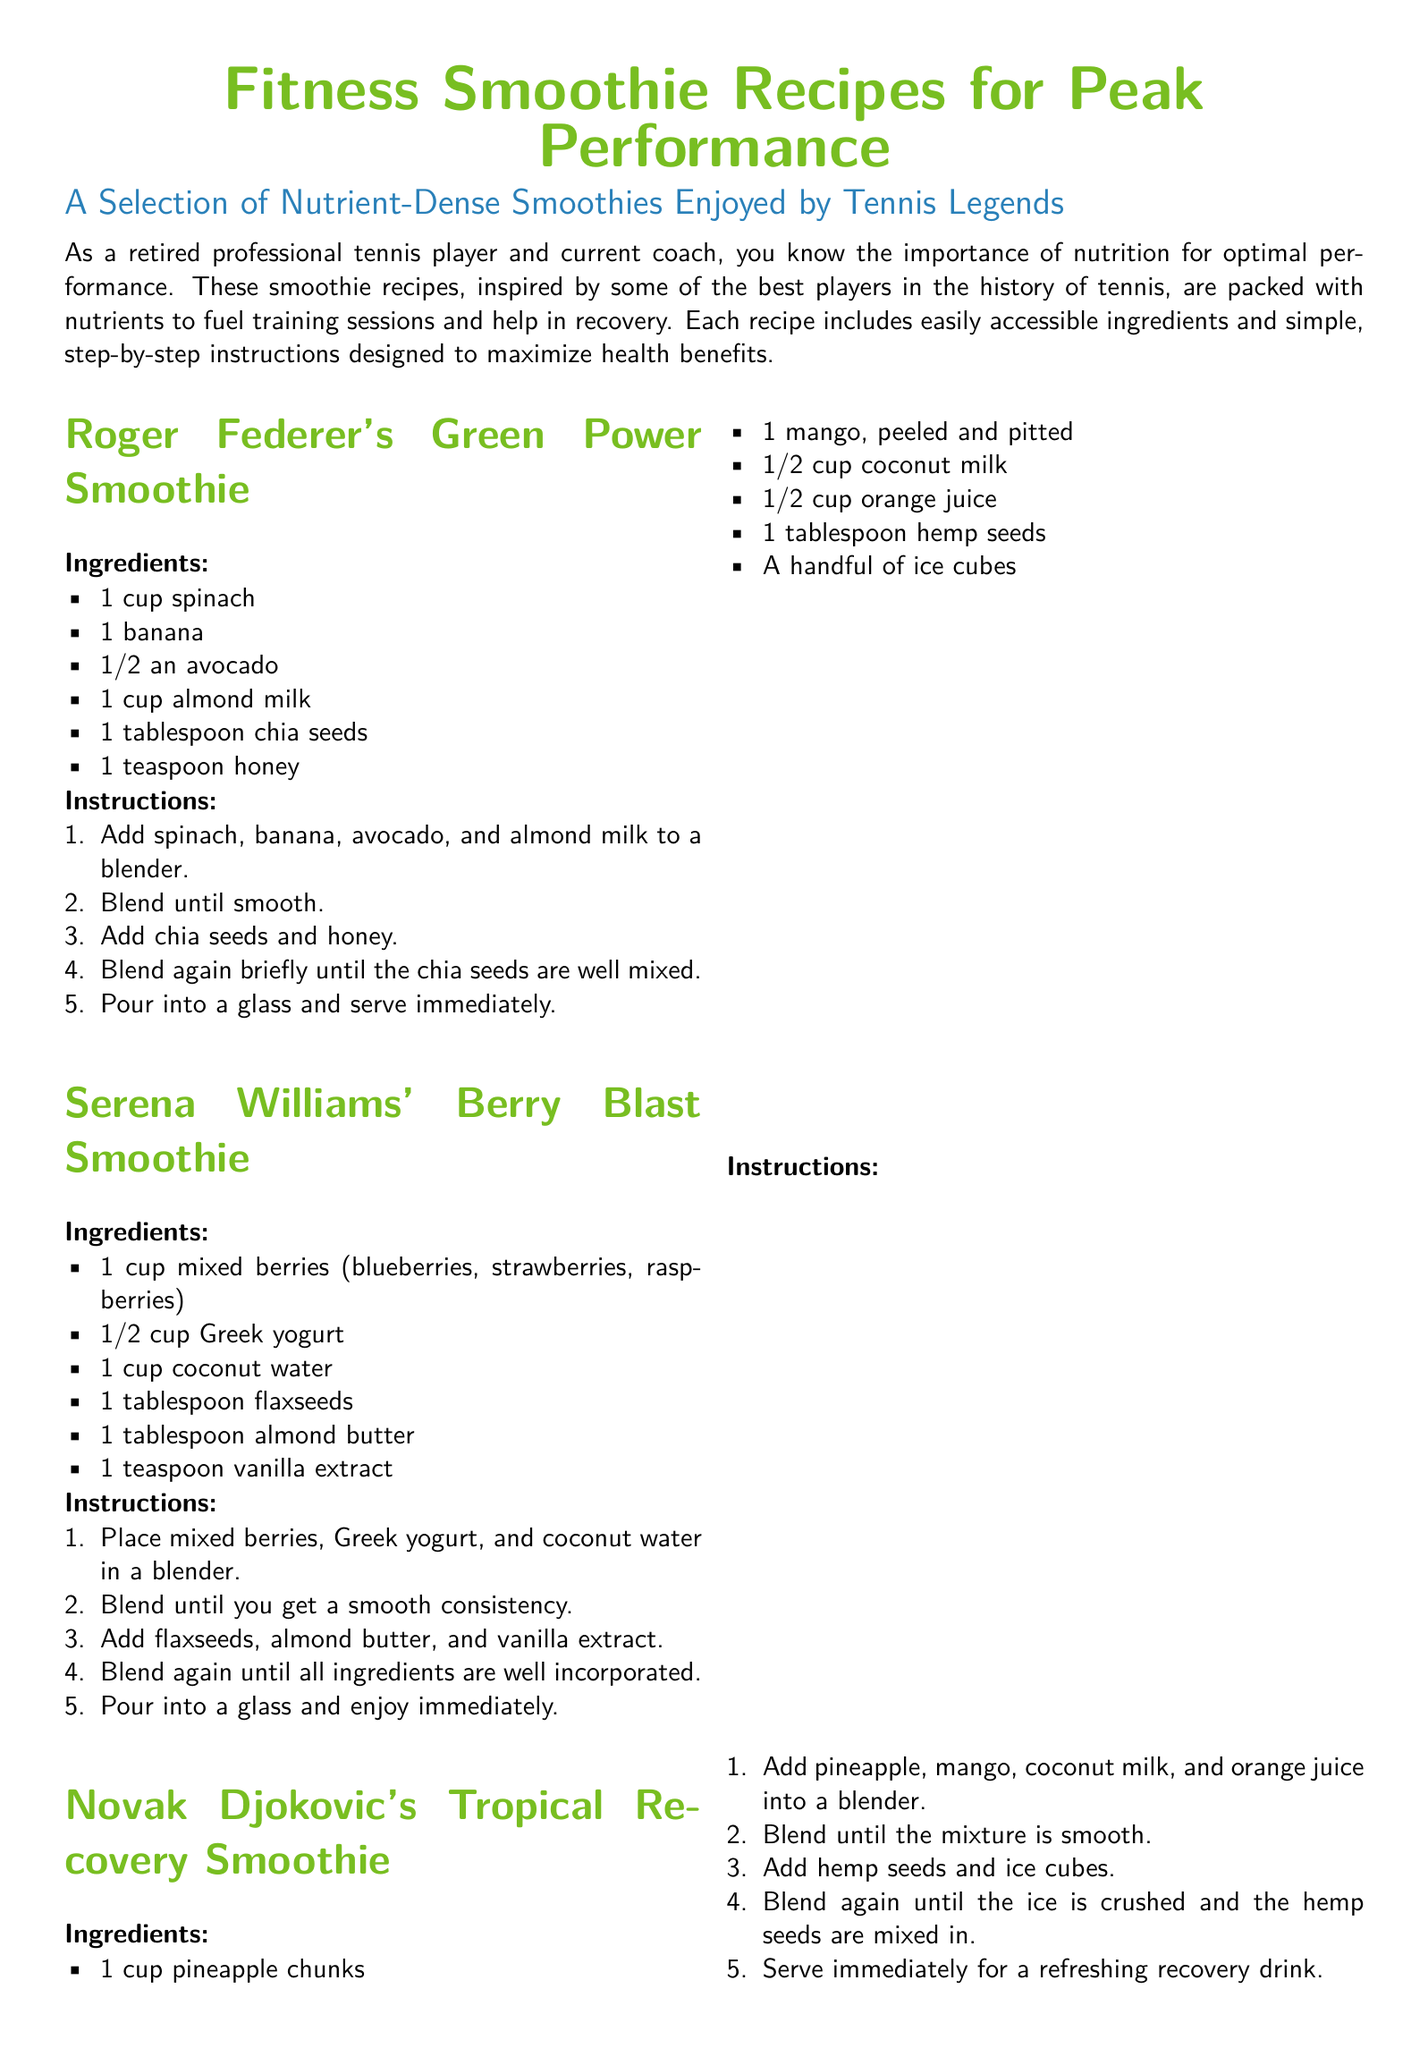What is the first ingredient in Roger Federer's smoothie? The first ingredient listed for Roger Federer's Green Power Smoothie is spinach.
Answer: spinach How many ingredients are in Serena Williams' Berry Blast Smoothie? The ingredients for Serena Williams' smoothie total six items, as listed under her recipe.
Answer: 6 Which player’s smoothie includes turmeric? Maria Sharapova's smoothie is specifically noted for containing turmeric.
Answer: Maria Sharapova What is a common main ingredient in all smoothies listed? Each smoothie contains a type of fruit as a main ingredient, such as banana or berries.
Answer: fruit What is the serving suggestion for Novak Djokovic's smoothie? The document states that Novak Djokovic's smoothie should be served immediately.
Answer: immediately How many smoothies are featured in the document? The document provides a total of five distinct smoothie recipes.
Answer: 5 Which smoothie is described as protein-packed? The recipe for Rafael Nadal's smoothie is described as protein-packed.
Answer: Rafael Nadal's Protein-Packed Banana Smoothie What is used for sweetness in Maria Sharapova's smoothie? Maple syrup is utilized for sweetness in Maria Sharapova's Anti-Inflammatory Turmeric Smoothie.
Answer: maple syrup 